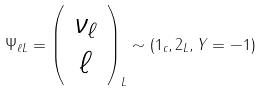Convert formula to latex. <formula><loc_0><loc_0><loc_500><loc_500>\Psi _ { \ell L } = \left ( \begin{array} { c } \nu _ { \ell } \\ \ell \end{array} \right ) _ { L } \sim ( { 1 } _ { c } , { 2 } _ { L } , Y = - 1 )</formula> 